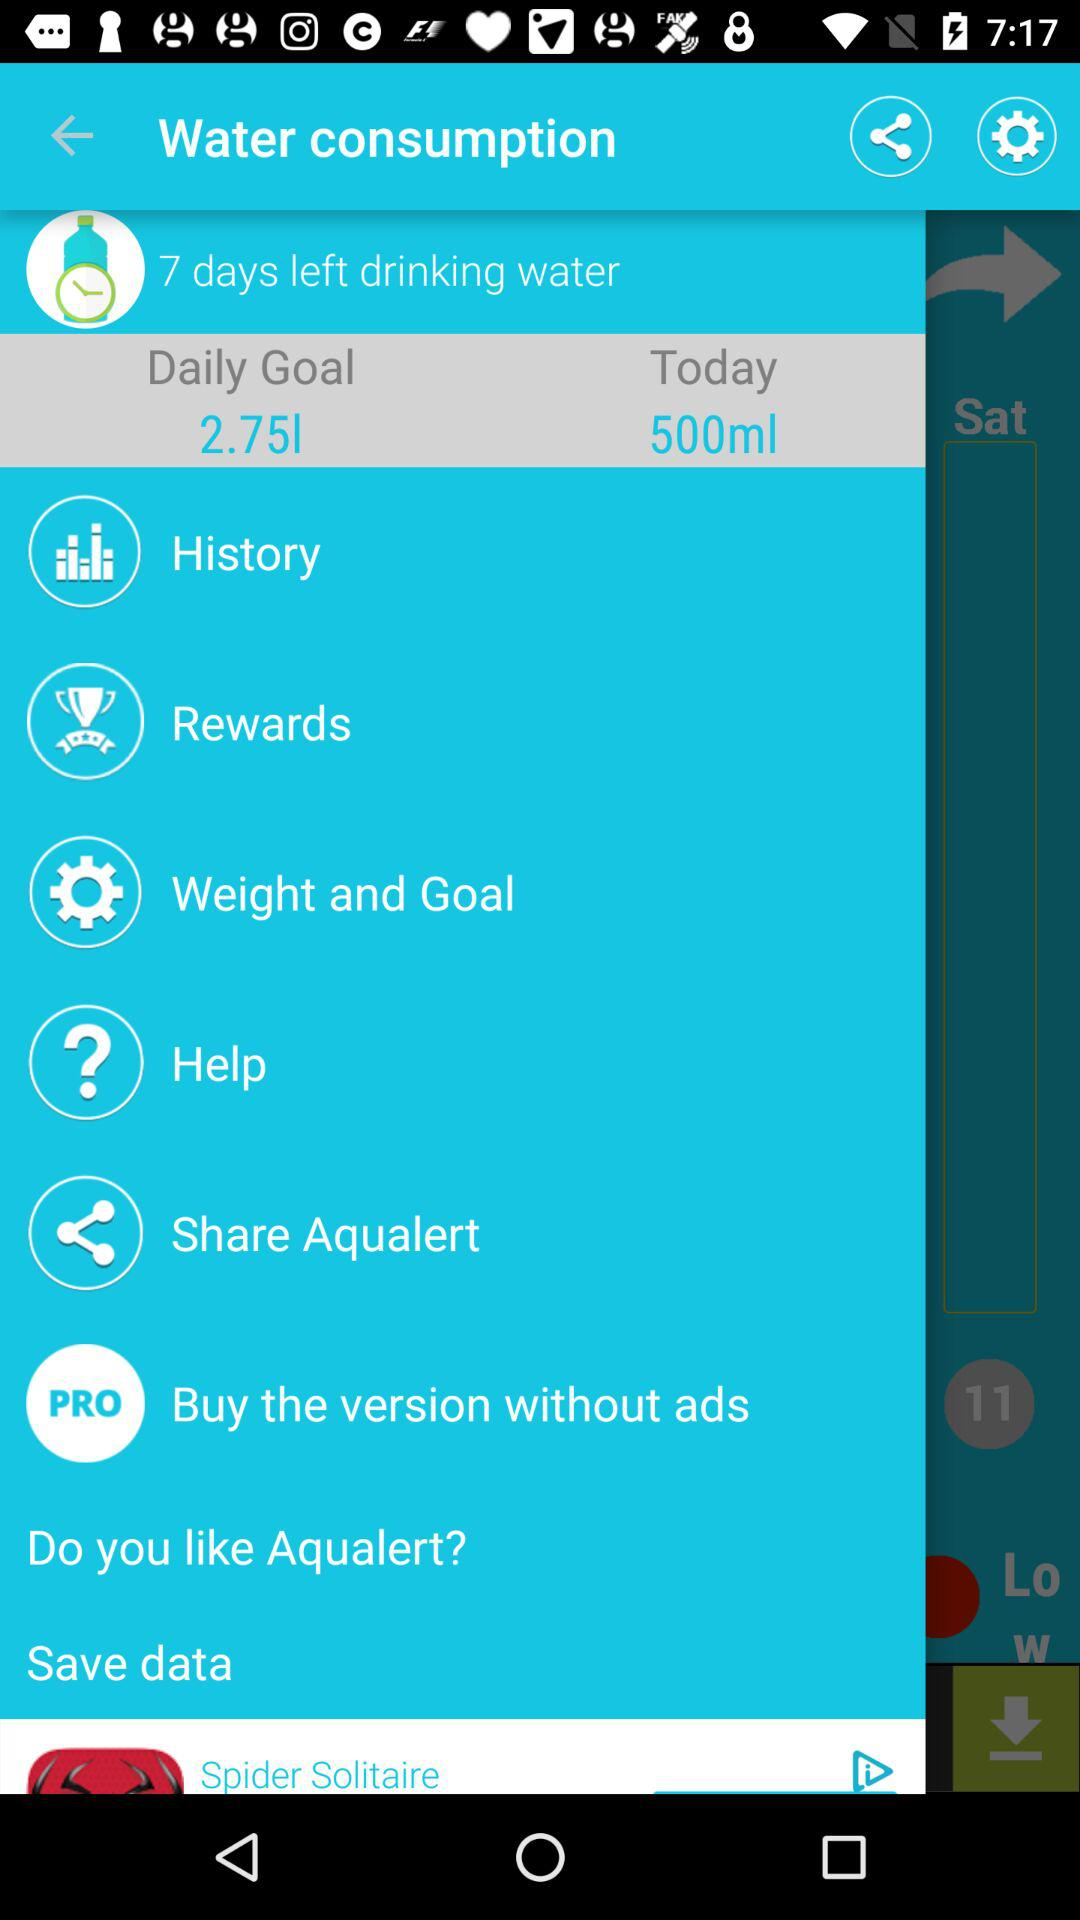What is the current water consumption? The current water consumption is 500 ml. 